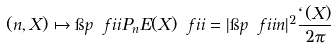<formula> <loc_0><loc_0><loc_500><loc_500>( n , X ) \mapsto \i p { \ f i i } { P _ { n } E ( X ) \ f i i } = | \i p { \ f i i } { n } | ^ { 2 } \frac { \ell ( X ) } { 2 \pi }</formula> 